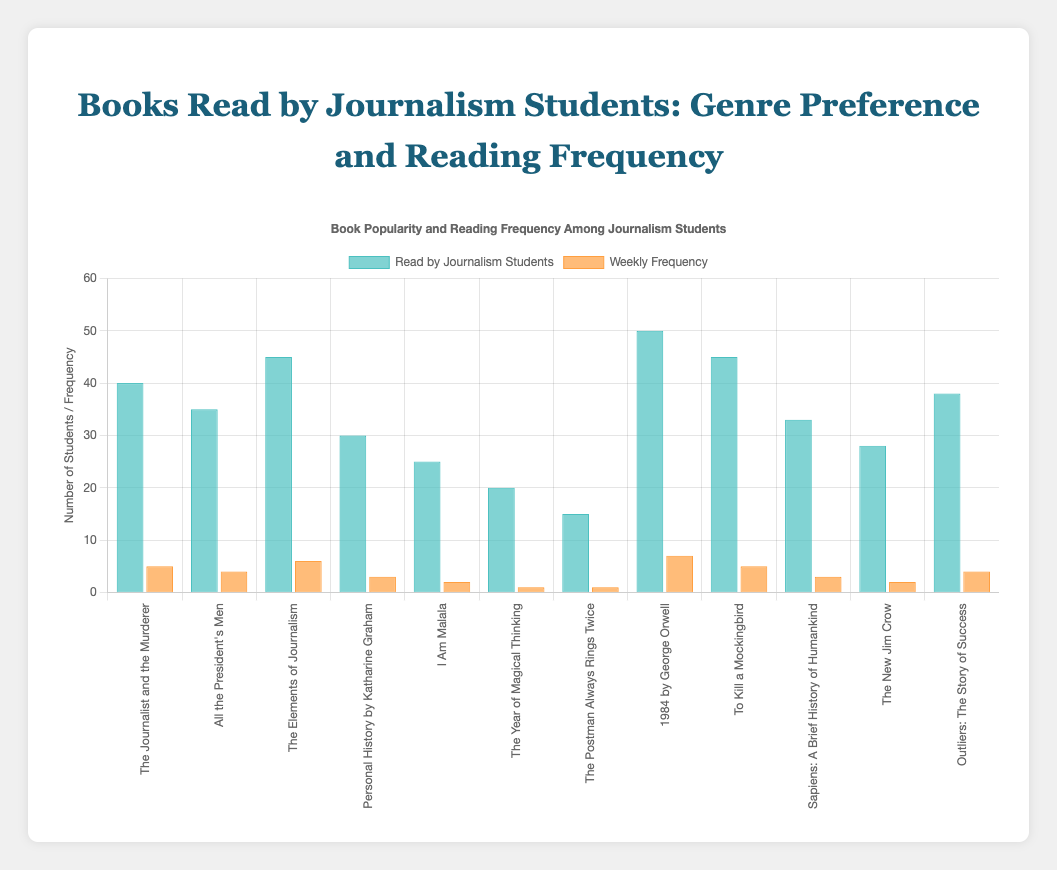Which book has the highest number of journalism students reading it? The book with the highest number of journalism students reading it will have the tallest bar in the 'Read by Journalism Students' dataset. By observing the chart, "1984 by George Orwell" has the tallest bar in this dataset.
Answer: 1984 by George Orwell Which book is read with the highest weekly frequency? To identify the book with the highest weekly frequency, look for the tallest bar in the 'Weekly Frequency' dataset. The "1984 by George Orwell" has the highest weekly frequency with the tallest bar in this dataset.
Answer: 1984 by George Orwell What is the total number of journalism students reading books in the genre "Investigative Journalism"? Sum the values of students reading the books in the "Investigative Journalism" genre: 40 + 35 + 45 = 120
Answer: 120 What is the difference in the number of journalism students between "Outliers: The Story of Success" and "The Journalist and the Murderer"? Subtract the number of students reading "The Journalist and the Murderer" from those reading "Outliers: The Story of Success": 38 - 40 = -2
Answer: -2 How does the frequency of reading "Sapiens: A Brief History of Humankind" compare to "Personal History by Katharine Graham"? Compare the height of the bars representing the weekly frequency of reading these two books. "Sapiens: A Brief History of Humankind" is read with a frequency of 3, equal to the frequency of "Personal History by Katharine Graham".
Answer: Equal Is there a significant difference in the reading frequency of "The Postman Always Rings Twice" and "I Am Malala"? Compare the height of the bars representing reading frequency for the two books. "The Postman Always Rings Twice" has a frequency of 1, which is less than "I Am Malala" with a frequency of 2.
Answer: No significant difference What is the average number of students reading books in the genre "Fiction"? Sum the number of students reading Fiction books and divide by the number of these books: (15 + 50 + 45) / 3 = 110 / 3 ≈ 36.67
Answer: 36.67 Are there any books read by fewer than 20 journalism students? Observe the heights of the bars representing the number of students for all books. Only "The Postman Always Rings Twice" and "The Year of Magical Thinking" have fewer than 20 students reading them.
Answer: Yes Compare the number of students reading "The Elements of Journalism" and "The Year of Magical Thinking". Look at the bar heights for both books. "The Elements of Journalism" has 45 students reading it, while "The Year of Magical Thinking" has 20.
Answer: The Elements of Journalism What is the total frequency of books read weekly in the genre "Non-Fiction"? Sum the weekly frequencies of all "Non-Fiction" books: 3 + 2 + 4 = 9
Answer: 9 